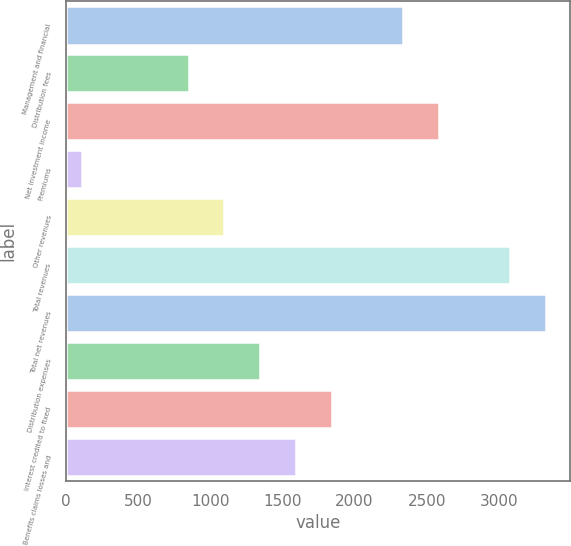<chart> <loc_0><loc_0><loc_500><loc_500><bar_chart><fcel>Management and financial<fcel>Distribution fees<fcel>Net investment income<fcel>Premiums<fcel>Other revenues<fcel>Total revenues<fcel>Total net revenues<fcel>Distribution expenses<fcel>Interest credited to fixed<fcel>Benefits claims losses and<nl><fcel>2335.7<fcel>851.9<fcel>2583<fcel>110<fcel>1099.2<fcel>3077.6<fcel>3324.9<fcel>1346.5<fcel>1841.1<fcel>1593.8<nl></chart> 